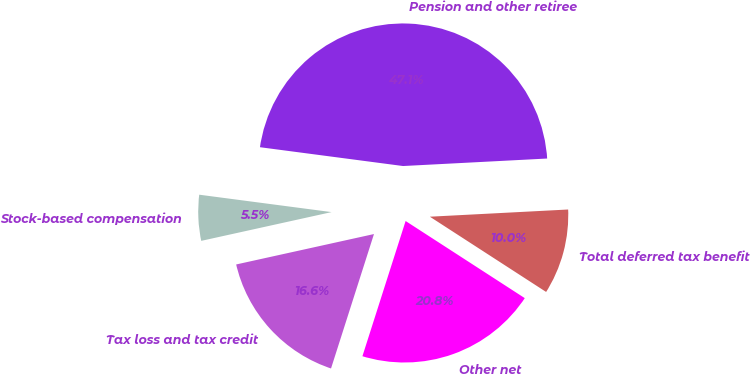Convert chart. <chart><loc_0><loc_0><loc_500><loc_500><pie_chart><fcel>Pension and other retiree<fcel>Stock-based compensation<fcel>Tax loss and tax credit<fcel>Other net<fcel>Total deferred tax benefit<nl><fcel>47.09%<fcel>5.54%<fcel>16.62%<fcel>20.78%<fcel>9.97%<nl></chart> 